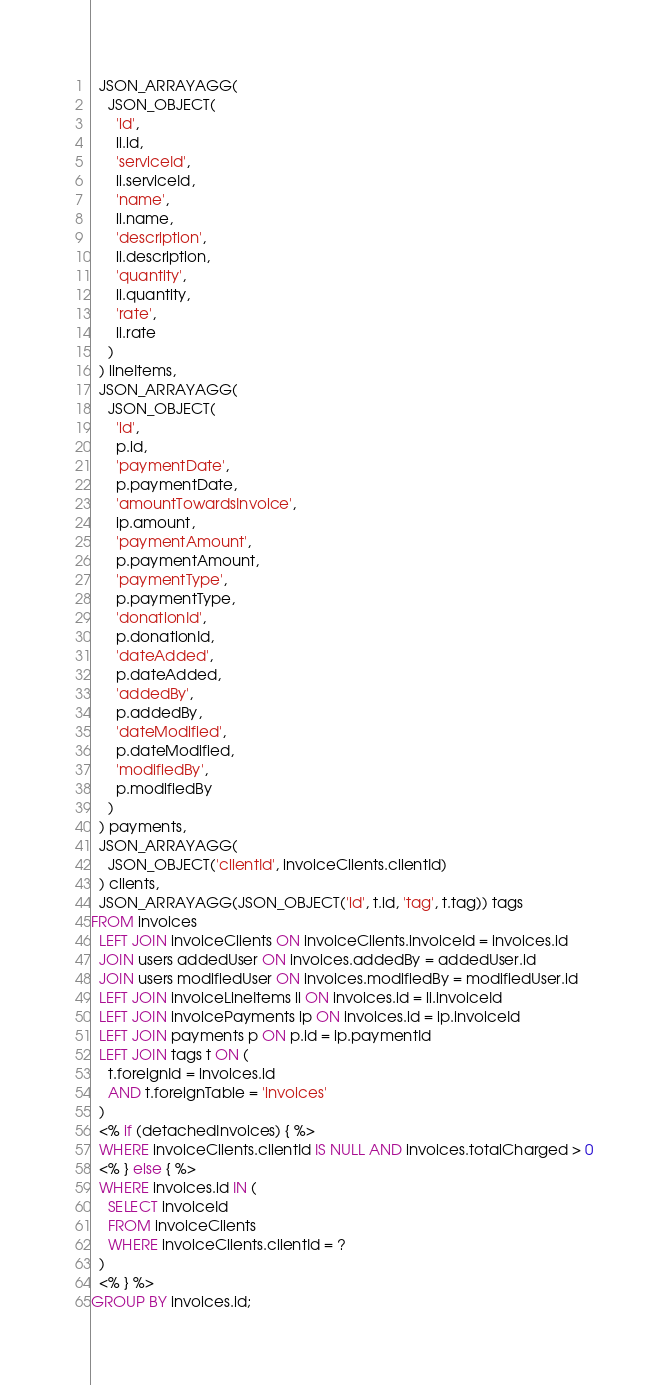<code> <loc_0><loc_0><loc_500><loc_500><_SQL_>  JSON_ARRAYAGG(
    JSON_OBJECT(
      'id',
      li.id,
      'serviceId',
      li.serviceId,
      'name',
      li.name,
      'description',
      li.description,
      'quantity',
      li.quantity,
      'rate',
      li.rate
    )
  ) lineItems,
  JSON_ARRAYAGG(
    JSON_OBJECT(
      'id',
      p.id,
      'paymentDate',
      p.paymentDate,
      'amountTowardsInvoice',
      ip.amount,
      'paymentAmount',
      p.paymentAmount,
      'paymentType',
      p.paymentType,
      'donationId',
      p.donationId,
      'dateAdded',
      p.dateAdded,
      'addedBy',
      p.addedBy,
      'dateModified',
      p.dateModified,
      'modifiedBy',
      p.modifiedBy
    )
  ) payments,
  JSON_ARRAYAGG(
    JSON_OBJECT('clientId', invoiceClients.clientId)
  ) clients,
  JSON_ARRAYAGG(JSON_OBJECT('id', t.id, 'tag', t.tag)) tags
FROM invoices
  LEFT JOIN invoiceClients ON invoiceClients.invoiceId = invoices.id
  JOIN users addedUser ON invoices.addedBy = addedUser.id
  JOIN users modifiedUser ON invoices.modifiedBy = modifiedUser.id
  LEFT JOIN invoiceLineItems li ON invoices.id = li.invoiceId
  LEFT JOIN invoicePayments ip ON invoices.id = ip.invoiceId
  LEFT JOIN payments p ON p.id = ip.paymentId
  LEFT JOIN tags t ON (
    t.foreignId = invoices.id
    AND t.foreignTable = 'invoices'
  )
  <% if (detachedInvoices) { %>
  WHERE invoiceClients.clientId IS NULL AND invoices.totalCharged > 0
  <% } else { %>
  WHERE invoices.id IN (
    SELECT invoiceId
    FROM invoiceClients
    WHERE invoiceClients.clientId = ?
  )
  <% } %>
GROUP BY invoices.id;</code> 